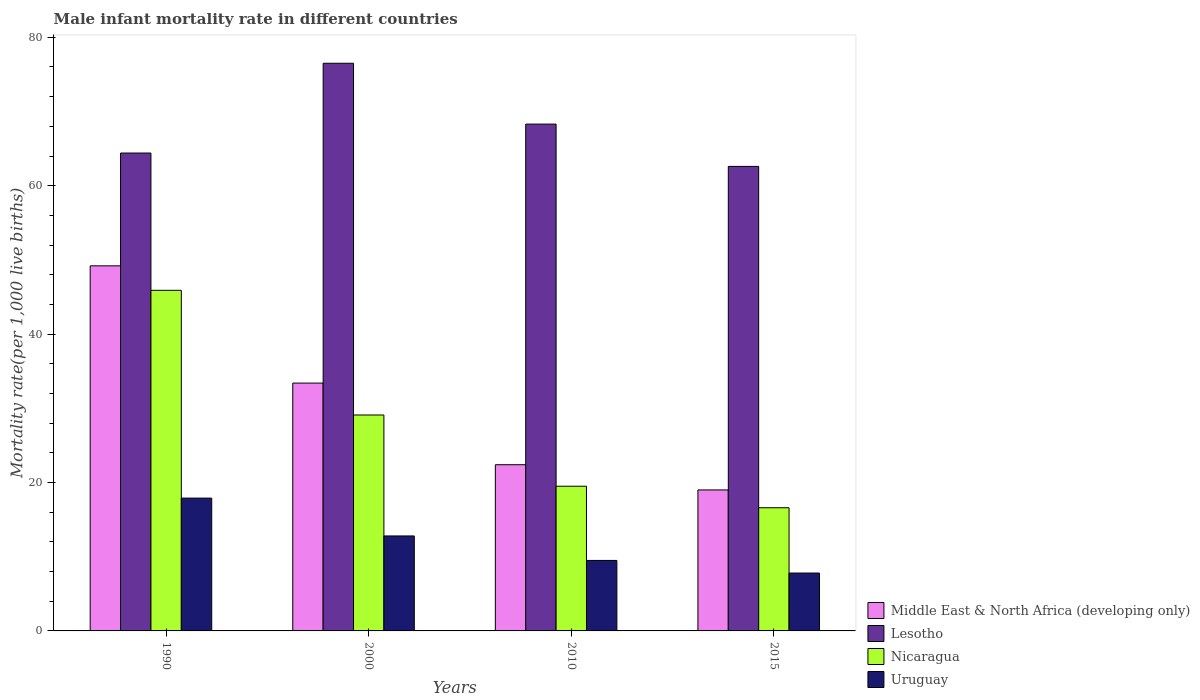Are the number of bars per tick equal to the number of legend labels?
Ensure brevity in your answer.  Yes. What is the label of the 4th group of bars from the left?
Your answer should be compact. 2015. What is the male infant mortality rate in Lesotho in 2000?
Offer a terse response. 76.5. Across all years, what is the maximum male infant mortality rate in Uruguay?
Keep it short and to the point. 17.9. In which year was the male infant mortality rate in Nicaragua maximum?
Ensure brevity in your answer.  1990. In which year was the male infant mortality rate in Nicaragua minimum?
Provide a short and direct response. 2015. What is the total male infant mortality rate in Lesotho in the graph?
Keep it short and to the point. 271.8. What is the difference between the male infant mortality rate in Uruguay in 1990 and that in 2010?
Your answer should be compact. 8.4. What is the difference between the male infant mortality rate in Lesotho in 2010 and the male infant mortality rate in Uruguay in 1990?
Ensure brevity in your answer.  50.4. What is the average male infant mortality rate in Nicaragua per year?
Make the answer very short. 27.77. In the year 2000, what is the difference between the male infant mortality rate in Nicaragua and male infant mortality rate in Middle East & North Africa (developing only)?
Your answer should be very brief. -4.3. In how many years, is the male infant mortality rate in Nicaragua greater than 12?
Your answer should be compact. 4. What is the ratio of the male infant mortality rate in Nicaragua in 1990 to that in 2010?
Keep it short and to the point. 2.35. Is the male infant mortality rate in Nicaragua in 2000 less than that in 2015?
Give a very brief answer. No. What is the difference between the highest and the second highest male infant mortality rate in Middle East & North Africa (developing only)?
Keep it short and to the point. 15.8. What is the difference between the highest and the lowest male infant mortality rate in Middle East & North Africa (developing only)?
Your answer should be very brief. 30.2. What does the 2nd bar from the left in 2015 represents?
Make the answer very short. Lesotho. What does the 1st bar from the right in 1990 represents?
Ensure brevity in your answer.  Uruguay. Are all the bars in the graph horizontal?
Keep it short and to the point. No. What is the difference between two consecutive major ticks on the Y-axis?
Your response must be concise. 20. Are the values on the major ticks of Y-axis written in scientific E-notation?
Ensure brevity in your answer.  No. Does the graph contain grids?
Give a very brief answer. No. How are the legend labels stacked?
Offer a very short reply. Vertical. What is the title of the graph?
Provide a short and direct response. Male infant mortality rate in different countries. What is the label or title of the X-axis?
Keep it short and to the point. Years. What is the label or title of the Y-axis?
Offer a very short reply. Mortality rate(per 1,0 live births). What is the Mortality rate(per 1,000 live births) of Middle East & North Africa (developing only) in 1990?
Your answer should be very brief. 49.2. What is the Mortality rate(per 1,000 live births) in Lesotho in 1990?
Your answer should be very brief. 64.4. What is the Mortality rate(per 1,000 live births) of Nicaragua in 1990?
Your answer should be very brief. 45.9. What is the Mortality rate(per 1,000 live births) of Middle East & North Africa (developing only) in 2000?
Ensure brevity in your answer.  33.4. What is the Mortality rate(per 1,000 live births) in Lesotho in 2000?
Your response must be concise. 76.5. What is the Mortality rate(per 1,000 live births) in Nicaragua in 2000?
Provide a short and direct response. 29.1. What is the Mortality rate(per 1,000 live births) of Middle East & North Africa (developing only) in 2010?
Your answer should be very brief. 22.4. What is the Mortality rate(per 1,000 live births) of Lesotho in 2010?
Offer a very short reply. 68.3. What is the Mortality rate(per 1,000 live births) of Nicaragua in 2010?
Ensure brevity in your answer.  19.5. What is the Mortality rate(per 1,000 live births) in Uruguay in 2010?
Give a very brief answer. 9.5. What is the Mortality rate(per 1,000 live births) in Middle East & North Africa (developing only) in 2015?
Provide a short and direct response. 19. What is the Mortality rate(per 1,000 live births) in Lesotho in 2015?
Your answer should be compact. 62.6. Across all years, what is the maximum Mortality rate(per 1,000 live births) of Middle East & North Africa (developing only)?
Keep it short and to the point. 49.2. Across all years, what is the maximum Mortality rate(per 1,000 live births) in Lesotho?
Keep it short and to the point. 76.5. Across all years, what is the maximum Mortality rate(per 1,000 live births) of Nicaragua?
Offer a terse response. 45.9. Across all years, what is the minimum Mortality rate(per 1,000 live births) in Lesotho?
Offer a terse response. 62.6. What is the total Mortality rate(per 1,000 live births) in Middle East & North Africa (developing only) in the graph?
Give a very brief answer. 124. What is the total Mortality rate(per 1,000 live births) of Lesotho in the graph?
Provide a succinct answer. 271.8. What is the total Mortality rate(per 1,000 live births) in Nicaragua in the graph?
Offer a terse response. 111.1. What is the total Mortality rate(per 1,000 live births) in Uruguay in the graph?
Provide a short and direct response. 48. What is the difference between the Mortality rate(per 1,000 live births) in Lesotho in 1990 and that in 2000?
Give a very brief answer. -12.1. What is the difference between the Mortality rate(per 1,000 live births) of Nicaragua in 1990 and that in 2000?
Make the answer very short. 16.8. What is the difference between the Mortality rate(per 1,000 live births) in Uruguay in 1990 and that in 2000?
Offer a terse response. 5.1. What is the difference between the Mortality rate(per 1,000 live births) of Middle East & North Africa (developing only) in 1990 and that in 2010?
Make the answer very short. 26.8. What is the difference between the Mortality rate(per 1,000 live births) in Lesotho in 1990 and that in 2010?
Your answer should be very brief. -3.9. What is the difference between the Mortality rate(per 1,000 live births) of Nicaragua in 1990 and that in 2010?
Offer a very short reply. 26.4. What is the difference between the Mortality rate(per 1,000 live births) in Uruguay in 1990 and that in 2010?
Your answer should be compact. 8.4. What is the difference between the Mortality rate(per 1,000 live births) of Middle East & North Africa (developing only) in 1990 and that in 2015?
Make the answer very short. 30.2. What is the difference between the Mortality rate(per 1,000 live births) in Lesotho in 1990 and that in 2015?
Ensure brevity in your answer.  1.8. What is the difference between the Mortality rate(per 1,000 live births) in Nicaragua in 1990 and that in 2015?
Provide a short and direct response. 29.3. What is the difference between the Mortality rate(per 1,000 live births) in Nicaragua in 2000 and that in 2010?
Offer a terse response. 9.6. What is the difference between the Mortality rate(per 1,000 live births) in Lesotho in 2000 and that in 2015?
Ensure brevity in your answer.  13.9. What is the difference between the Mortality rate(per 1,000 live births) of Middle East & North Africa (developing only) in 2010 and that in 2015?
Ensure brevity in your answer.  3.4. What is the difference between the Mortality rate(per 1,000 live births) of Nicaragua in 2010 and that in 2015?
Give a very brief answer. 2.9. What is the difference between the Mortality rate(per 1,000 live births) of Middle East & North Africa (developing only) in 1990 and the Mortality rate(per 1,000 live births) of Lesotho in 2000?
Your response must be concise. -27.3. What is the difference between the Mortality rate(per 1,000 live births) of Middle East & North Africa (developing only) in 1990 and the Mortality rate(per 1,000 live births) of Nicaragua in 2000?
Offer a very short reply. 20.1. What is the difference between the Mortality rate(per 1,000 live births) of Middle East & North Africa (developing only) in 1990 and the Mortality rate(per 1,000 live births) of Uruguay in 2000?
Offer a very short reply. 36.4. What is the difference between the Mortality rate(per 1,000 live births) in Lesotho in 1990 and the Mortality rate(per 1,000 live births) in Nicaragua in 2000?
Your response must be concise. 35.3. What is the difference between the Mortality rate(per 1,000 live births) of Lesotho in 1990 and the Mortality rate(per 1,000 live births) of Uruguay in 2000?
Make the answer very short. 51.6. What is the difference between the Mortality rate(per 1,000 live births) of Nicaragua in 1990 and the Mortality rate(per 1,000 live births) of Uruguay in 2000?
Give a very brief answer. 33.1. What is the difference between the Mortality rate(per 1,000 live births) of Middle East & North Africa (developing only) in 1990 and the Mortality rate(per 1,000 live births) of Lesotho in 2010?
Offer a very short reply. -19.1. What is the difference between the Mortality rate(per 1,000 live births) in Middle East & North Africa (developing only) in 1990 and the Mortality rate(per 1,000 live births) in Nicaragua in 2010?
Ensure brevity in your answer.  29.7. What is the difference between the Mortality rate(per 1,000 live births) of Middle East & North Africa (developing only) in 1990 and the Mortality rate(per 1,000 live births) of Uruguay in 2010?
Provide a succinct answer. 39.7. What is the difference between the Mortality rate(per 1,000 live births) of Lesotho in 1990 and the Mortality rate(per 1,000 live births) of Nicaragua in 2010?
Offer a terse response. 44.9. What is the difference between the Mortality rate(per 1,000 live births) in Lesotho in 1990 and the Mortality rate(per 1,000 live births) in Uruguay in 2010?
Provide a succinct answer. 54.9. What is the difference between the Mortality rate(per 1,000 live births) of Nicaragua in 1990 and the Mortality rate(per 1,000 live births) of Uruguay in 2010?
Your answer should be compact. 36.4. What is the difference between the Mortality rate(per 1,000 live births) of Middle East & North Africa (developing only) in 1990 and the Mortality rate(per 1,000 live births) of Lesotho in 2015?
Your answer should be very brief. -13.4. What is the difference between the Mortality rate(per 1,000 live births) of Middle East & North Africa (developing only) in 1990 and the Mortality rate(per 1,000 live births) of Nicaragua in 2015?
Your response must be concise. 32.6. What is the difference between the Mortality rate(per 1,000 live births) in Middle East & North Africa (developing only) in 1990 and the Mortality rate(per 1,000 live births) in Uruguay in 2015?
Give a very brief answer. 41.4. What is the difference between the Mortality rate(per 1,000 live births) of Lesotho in 1990 and the Mortality rate(per 1,000 live births) of Nicaragua in 2015?
Give a very brief answer. 47.8. What is the difference between the Mortality rate(per 1,000 live births) in Lesotho in 1990 and the Mortality rate(per 1,000 live births) in Uruguay in 2015?
Your response must be concise. 56.6. What is the difference between the Mortality rate(per 1,000 live births) of Nicaragua in 1990 and the Mortality rate(per 1,000 live births) of Uruguay in 2015?
Provide a succinct answer. 38.1. What is the difference between the Mortality rate(per 1,000 live births) of Middle East & North Africa (developing only) in 2000 and the Mortality rate(per 1,000 live births) of Lesotho in 2010?
Make the answer very short. -34.9. What is the difference between the Mortality rate(per 1,000 live births) of Middle East & North Africa (developing only) in 2000 and the Mortality rate(per 1,000 live births) of Nicaragua in 2010?
Make the answer very short. 13.9. What is the difference between the Mortality rate(per 1,000 live births) of Middle East & North Africa (developing only) in 2000 and the Mortality rate(per 1,000 live births) of Uruguay in 2010?
Give a very brief answer. 23.9. What is the difference between the Mortality rate(per 1,000 live births) of Lesotho in 2000 and the Mortality rate(per 1,000 live births) of Nicaragua in 2010?
Keep it short and to the point. 57. What is the difference between the Mortality rate(per 1,000 live births) in Nicaragua in 2000 and the Mortality rate(per 1,000 live births) in Uruguay in 2010?
Make the answer very short. 19.6. What is the difference between the Mortality rate(per 1,000 live births) of Middle East & North Africa (developing only) in 2000 and the Mortality rate(per 1,000 live births) of Lesotho in 2015?
Your answer should be very brief. -29.2. What is the difference between the Mortality rate(per 1,000 live births) in Middle East & North Africa (developing only) in 2000 and the Mortality rate(per 1,000 live births) in Uruguay in 2015?
Provide a short and direct response. 25.6. What is the difference between the Mortality rate(per 1,000 live births) of Lesotho in 2000 and the Mortality rate(per 1,000 live births) of Nicaragua in 2015?
Keep it short and to the point. 59.9. What is the difference between the Mortality rate(per 1,000 live births) in Lesotho in 2000 and the Mortality rate(per 1,000 live births) in Uruguay in 2015?
Give a very brief answer. 68.7. What is the difference between the Mortality rate(per 1,000 live births) in Nicaragua in 2000 and the Mortality rate(per 1,000 live births) in Uruguay in 2015?
Give a very brief answer. 21.3. What is the difference between the Mortality rate(per 1,000 live births) in Middle East & North Africa (developing only) in 2010 and the Mortality rate(per 1,000 live births) in Lesotho in 2015?
Your answer should be very brief. -40.2. What is the difference between the Mortality rate(per 1,000 live births) in Lesotho in 2010 and the Mortality rate(per 1,000 live births) in Nicaragua in 2015?
Provide a succinct answer. 51.7. What is the difference between the Mortality rate(per 1,000 live births) of Lesotho in 2010 and the Mortality rate(per 1,000 live births) of Uruguay in 2015?
Keep it short and to the point. 60.5. What is the average Mortality rate(per 1,000 live births) of Lesotho per year?
Your response must be concise. 67.95. What is the average Mortality rate(per 1,000 live births) of Nicaragua per year?
Your answer should be very brief. 27.77. In the year 1990, what is the difference between the Mortality rate(per 1,000 live births) in Middle East & North Africa (developing only) and Mortality rate(per 1,000 live births) in Lesotho?
Offer a very short reply. -15.2. In the year 1990, what is the difference between the Mortality rate(per 1,000 live births) in Middle East & North Africa (developing only) and Mortality rate(per 1,000 live births) in Nicaragua?
Make the answer very short. 3.3. In the year 1990, what is the difference between the Mortality rate(per 1,000 live births) of Middle East & North Africa (developing only) and Mortality rate(per 1,000 live births) of Uruguay?
Provide a succinct answer. 31.3. In the year 1990, what is the difference between the Mortality rate(per 1,000 live births) in Lesotho and Mortality rate(per 1,000 live births) in Uruguay?
Your response must be concise. 46.5. In the year 1990, what is the difference between the Mortality rate(per 1,000 live births) of Nicaragua and Mortality rate(per 1,000 live births) of Uruguay?
Ensure brevity in your answer.  28. In the year 2000, what is the difference between the Mortality rate(per 1,000 live births) in Middle East & North Africa (developing only) and Mortality rate(per 1,000 live births) in Lesotho?
Provide a succinct answer. -43.1. In the year 2000, what is the difference between the Mortality rate(per 1,000 live births) of Middle East & North Africa (developing only) and Mortality rate(per 1,000 live births) of Nicaragua?
Ensure brevity in your answer.  4.3. In the year 2000, what is the difference between the Mortality rate(per 1,000 live births) in Middle East & North Africa (developing only) and Mortality rate(per 1,000 live births) in Uruguay?
Your answer should be compact. 20.6. In the year 2000, what is the difference between the Mortality rate(per 1,000 live births) of Lesotho and Mortality rate(per 1,000 live births) of Nicaragua?
Offer a very short reply. 47.4. In the year 2000, what is the difference between the Mortality rate(per 1,000 live births) in Lesotho and Mortality rate(per 1,000 live births) in Uruguay?
Give a very brief answer. 63.7. In the year 2000, what is the difference between the Mortality rate(per 1,000 live births) of Nicaragua and Mortality rate(per 1,000 live births) of Uruguay?
Your answer should be very brief. 16.3. In the year 2010, what is the difference between the Mortality rate(per 1,000 live births) in Middle East & North Africa (developing only) and Mortality rate(per 1,000 live births) in Lesotho?
Offer a very short reply. -45.9. In the year 2010, what is the difference between the Mortality rate(per 1,000 live births) of Middle East & North Africa (developing only) and Mortality rate(per 1,000 live births) of Nicaragua?
Your answer should be very brief. 2.9. In the year 2010, what is the difference between the Mortality rate(per 1,000 live births) of Lesotho and Mortality rate(per 1,000 live births) of Nicaragua?
Provide a short and direct response. 48.8. In the year 2010, what is the difference between the Mortality rate(per 1,000 live births) of Lesotho and Mortality rate(per 1,000 live births) of Uruguay?
Give a very brief answer. 58.8. In the year 2015, what is the difference between the Mortality rate(per 1,000 live births) of Middle East & North Africa (developing only) and Mortality rate(per 1,000 live births) of Lesotho?
Your answer should be very brief. -43.6. In the year 2015, what is the difference between the Mortality rate(per 1,000 live births) in Lesotho and Mortality rate(per 1,000 live births) in Uruguay?
Keep it short and to the point. 54.8. In the year 2015, what is the difference between the Mortality rate(per 1,000 live births) of Nicaragua and Mortality rate(per 1,000 live births) of Uruguay?
Provide a succinct answer. 8.8. What is the ratio of the Mortality rate(per 1,000 live births) of Middle East & North Africa (developing only) in 1990 to that in 2000?
Provide a short and direct response. 1.47. What is the ratio of the Mortality rate(per 1,000 live births) of Lesotho in 1990 to that in 2000?
Offer a terse response. 0.84. What is the ratio of the Mortality rate(per 1,000 live births) in Nicaragua in 1990 to that in 2000?
Your answer should be compact. 1.58. What is the ratio of the Mortality rate(per 1,000 live births) in Uruguay in 1990 to that in 2000?
Offer a terse response. 1.4. What is the ratio of the Mortality rate(per 1,000 live births) of Middle East & North Africa (developing only) in 1990 to that in 2010?
Provide a succinct answer. 2.2. What is the ratio of the Mortality rate(per 1,000 live births) in Lesotho in 1990 to that in 2010?
Your answer should be very brief. 0.94. What is the ratio of the Mortality rate(per 1,000 live births) of Nicaragua in 1990 to that in 2010?
Ensure brevity in your answer.  2.35. What is the ratio of the Mortality rate(per 1,000 live births) in Uruguay in 1990 to that in 2010?
Make the answer very short. 1.88. What is the ratio of the Mortality rate(per 1,000 live births) of Middle East & North Africa (developing only) in 1990 to that in 2015?
Your response must be concise. 2.59. What is the ratio of the Mortality rate(per 1,000 live births) of Lesotho in 1990 to that in 2015?
Your answer should be very brief. 1.03. What is the ratio of the Mortality rate(per 1,000 live births) of Nicaragua in 1990 to that in 2015?
Offer a terse response. 2.77. What is the ratio of the Mortality rate(per 1,000 live births) in Uruguay in 1990 to that in 2015?
Offer a very short reply. 2.29. What is the ratio of the Mortality rate(per 1,000 live births) of Middle East & North Africa (developing only) in 2000 to that in 2010?
Provide a succinct answer. 1.49. What is the ratio of the Mortality rate(per 1,000 live births) of Lesotho in 2000 to that in 2010?
Give a very brief answer. 1.12. What is the ratio of the Mortality rate(per 1,000 live births) of Nicaragua in 2000 to that in 2010?
Your response must be concise. 1.49. What is the ratio of the Mortality rate(per 1,000 live births) in Uruguay in 2000 to that in 2010?
Provide a succinct answer. 1.35. What is the ratio of the Mortality rate(per 1,000 live births) of Middle East & North Africa (developing only) in 2000 to that in 2015?
Keep it short and to the point. 1.76. What is the ratio of the Mortality rate(per 1,000 live births) of Lesotho in 2000 to that in 2015?
Give a very brief answer. 1.22. What is the ratio of the Mortality rate(per 1,000 live births) in Nicaragua in 2000 to that in 2015?
Offer a terse response. 1.75. What is the ratio of the Mortality rate(per 1,000 live births) of Uruguay in 2000 to that in 2015?
Your answer should be very brief. 1.64. What is the ratio of the Mortality rate(per 1,000 live births) of Middle East & North Africa (developing only) in 2010 to that in 2015?
Make the answer very short. 1.18. What is the ratio of the Mortality rate(per 1,000 live births) of Lesotho in 2010 to that in 2015?
Your answer should be compact. 1.09. What is the ratio of the Mortality rate(per 1,000 live births) of Nicaragua in 2010 to that in 2015?
Give a very brief answer. 1.17. What is the ratio of the Mortality rate(per 1,000 live births) of Uruguay in 2010 to that in 2015?
Your response must be concise. 1.22. What is the difference between the highest and the second highest Mortality rate(per 1,000 live births) of Nicaragua?
Provide a succinct answer. 16.8. What is the difference between the highest and the second highest Mortality rate(per 1,000 live births) in Uruguay?
Provide a succinct answer. 5.1. What is the difference between the highest and the lowest Mortality rate(per 1,000 live births) in Middle East & North Africa (developing only)?
Give a very brief answer. 30.2. What is the difference between the highest and the lowest Mortality rate(per 1,000 live births) in Nicaragua?
Make the answer very short. 29.3. 